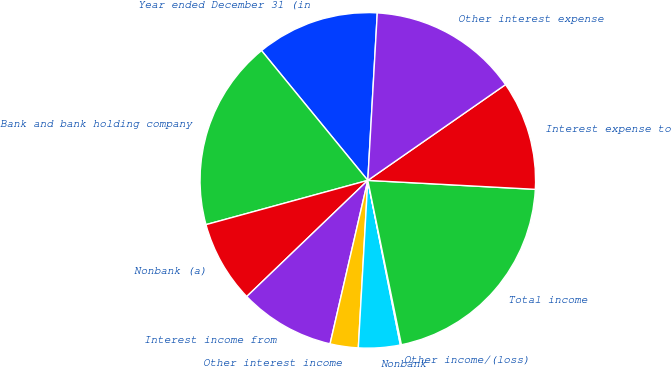Convert chart. <chart><loc_0><loc_0><loc_500><loc_500><pie_chart><fcel>Year ended December 31 (in<fcel>Bank and bank holding company<fcel>Nonbank (a)<fcel>Interest income from<fcel>Other interest income<fcel>Nonbank<fcel>Other income/(loss)<fcel>Total income<fcel>Interest expense to<fcel>Other interest expense<nl><fcel>11.82%<fcel>18.33%<fcel>7.92%<fcel>9.22%<fcel>2.71%<fcel>4.01%<fcel>0.1%<fcel>20.94%<fcel>10.52%<fcel>14.43%<nl></chart> 